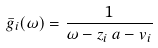<formula> <loc_0><loc_0><loc_500><loc_500>\bar { g } _ { i } ( \omega ) = \frac { 1 } { \omega - z _ { i } \, a - v _ { i } }</formula> 